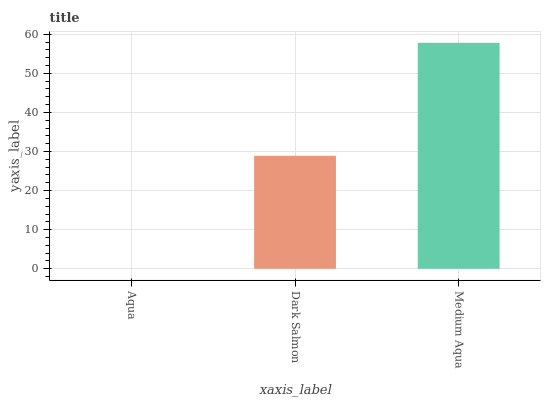Is Aqua the minimum?
Answer yes or no. Yes. Is Medium Aqua the maximum?
Answer yes or no. Yes. Is Dark Salmon the minimum?
Answer yes or no. No. Is Dark Salmon the maximum?
Answer yes or no. No. Is Dark Salmon greater than Aqua?
Answer yes or no. Yes. Is Aqua less than Dark Salmon?
Answer yes or no. Yes. Is Aqua greater than Dark Salmon?
Answer yes or no. No. Is Dark Salmon less than Aqua?
Answer yes or no. No. Is Dark Salmon the high median?
Answer yes or no. Yes. Is Dark Salmon the low median?
Answer yes or no. Yes. Is Medium Aqua the high median?
Answer yes or no. No. Is Medium Aqua the low median?
Answer yes or no. No. 